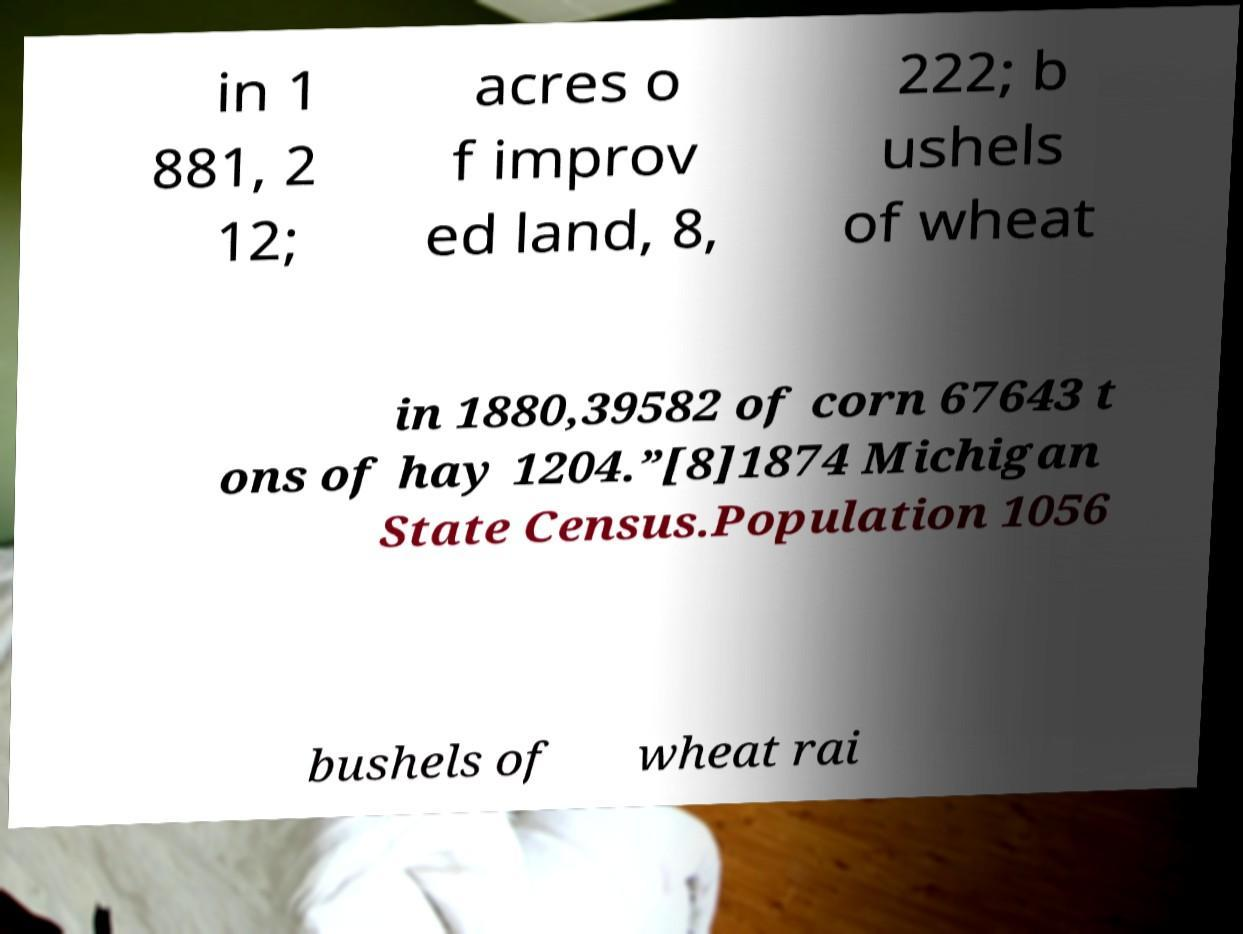Could you extract and type out the text from this image? in 1 881, 2 12; acres o f improv ed land, 8, 222; b ushels of wheat in 1880,39582 of corn 67643 t ons of hay 1204.”[8]1874 Michigan State Census.Population 1056 bushels of wheat rai 